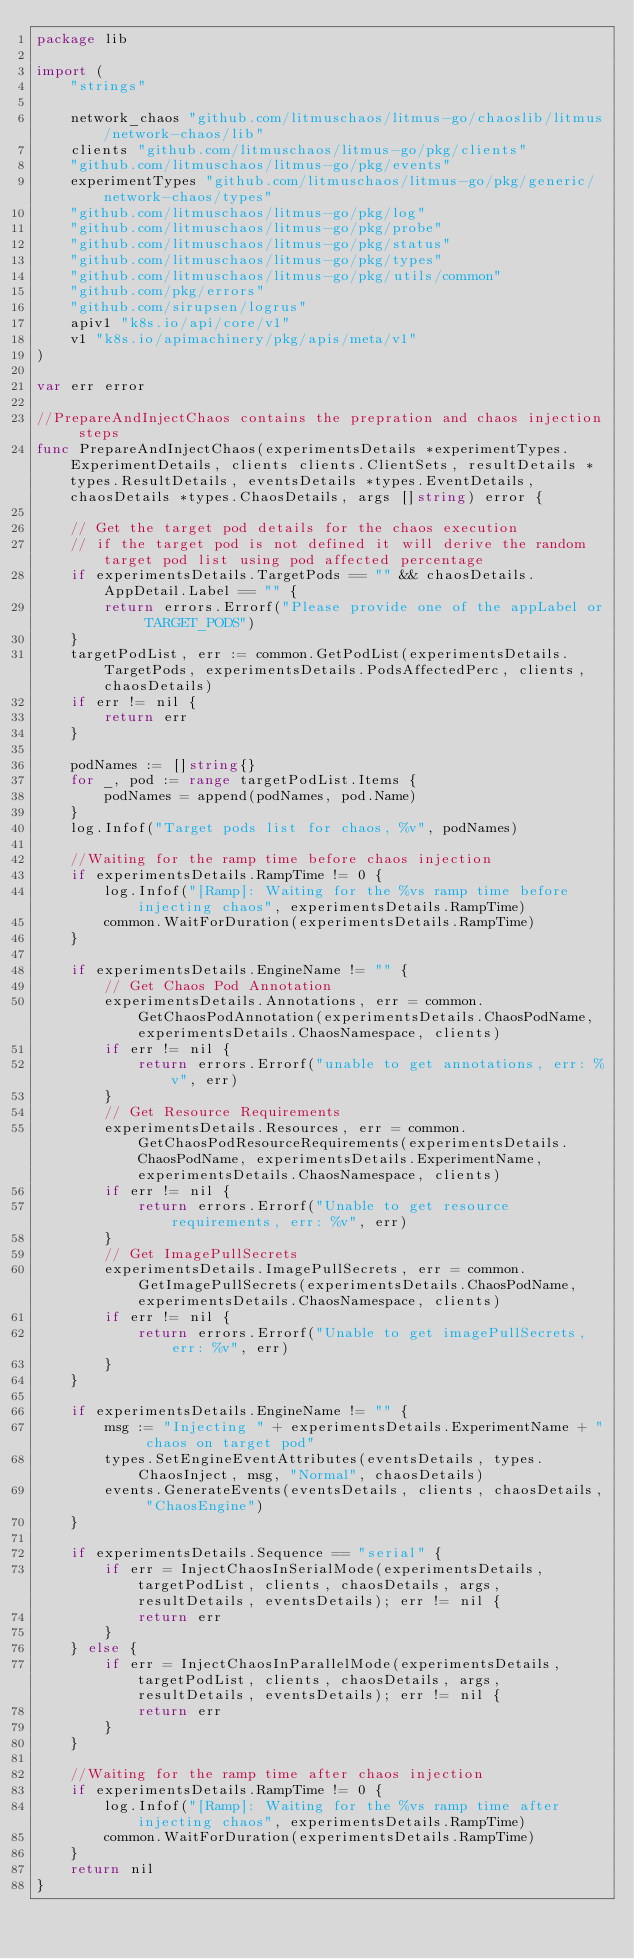<code> <loc_0><loc_0><loc_500><loc_500><_Go_>package lib

import (
	"strings"

	network_chaos "github.com/litmuschaos/litmus-go/chaoslib/litmus/network-chaos/lib"
	clients "github.com/litmuschaos/litmus-go/pkg/clients"
	"github.com/litmuschaos/litmus-go/pkg/events"
	experimentTypes "github.com/litmuschaos/litmus-go/pkg/generic/network-chaos/types"
	"github.com/litmuschaos/litmus-go/pkg/log"
	"github.com/litmuschaos/litmus-go/pkg/probe"
	"github.com/litmuschaos/litmus-go/pkg/status"
	"github.com/litmuschaos/litmus-go/pkg/types"
	"github.com/litmuschaos/litmus-go/pkg/utils/common"
	"github.com/pkg/errors"
	"github.com/sirupsen/logrus"
	apiv1 "k8s.io/api/core/v1"
	v1 "k8s.io/apimachinery/pkg/apis/meta/v1"
)

var err error

//PrepareAndInjectChaos contains the prepration and chaos injection steps
func PrepareAndInjectChaos(experimentsDetails *experimentTypes.ExperimentDetails, clients clients.ClientSets, resultDetails *types.ResultDetails, eventsDetails *types.EventDetails, chaosDetails *types.ChaosDetails, args []string) error {

	// Get the target pod details for the chaos execution
	// if the target pod is not defined it will derive the random target pod list using pod affected percentage
	if experimentsDetails.TargetPods == "" && chaosDetails.AppDetail.Label == "" {
		return errors.Errorf("Please provide one of the appLabel or TARGET_PODS")
	}
	targetPodList, err := common.GetPodList(experimentsDetails.TargetPods, experimentsDetails.PodsAffectedPerc, clients, chaosDetails)
	if err != nil {
		return err
	}

	podNames := []string{}
	for _, pod := range targetPodList.Items {
		podNames = append(podNames, pod.Name)
	}
	log.Infof("Target pods list for chaos, %v", podNames)

	//Waiting for the ramp time before chaos injection
	if experimentsDetails.RampTime != 0 {
		log.Infof("[Ramp]: Waiting for the %vs ramp time before injecting chaos", experimentsDetails.RampTime)
		common.WaitForDuration(experimentsDetails.RampTime)
	}

	if experimentsDetails.EngineName != "" {
		// Get Chaos Pod Annotation
		experimentsDetails.Annotations, err = common.GetChaosPodAnnotation(experimentsDetails.ChaosPodName, experimentsDetails.ChaosNamespace, clients)
		if err != nil {
			return errors.Errorf("unable to get annotations, err: %v", err)
		}
		// Get Resource Requirements
		experimentsDetails.Resources, err = common.GetChaosPodResourceRequirements(experimentsDetails.ChaosPodName, experimentsDetails.ExperimentName, experimentsDetails.ChaosNamespace, clients)
		if err != nil {
			return errors.Errorf("Unable to get resource requirements, err: %v", err)
		}
		// Get ImagePullSecrets
		experimentsDetails.ImagePullSecrets, err = common.GetImagePullSecrets(experimentsDetails.ChaosPodName, experimentsDetails.ChaosNamespace, clients)
		if err != nil {
			return errors.Errorf("Unable to get imagePullSecrets, err: %v", err)
		}
	}

	if experimentsDetails.EngineName != "" {
		msg := "Injecting " + experimentsDetails.ExperimentName + " chaos on target pod"
		types.SetEngineEventAttributes(eventsDetails, types.ChaosInject, msg, "Normal", chaosDetails)
		events.GenerateEvents(eventsDetails, clients, chaosDetails, "ChaosEngine")
	}

	if experimentsDetails.Sequence == "serial" {
		if err = InjectChaosInSerialMode(experimentsDetails, targetPodList, clients, chaosDetails, args, resultDetails, eventsDetails); err != nil {
			return err
		}
	} else {
		if err = InjectChaosInParallelMode(experimentsDetails, targetPodList, clients, chaosDetails, args, resultDetails, eventsDetails); err != nil {
			return err
		}
	}

	//Waiting for the ramp time after chaos injection
	if experimentsDetails.RampTime != 0 {
		log.Infof("[Ramp]: Waiting for the %vs ramp time after injecting chaos", experimentsDetails.RampTime)
		common.WaitForDuration(experimentsDetails.RampTime)
	}
	return nil
}
</code> 